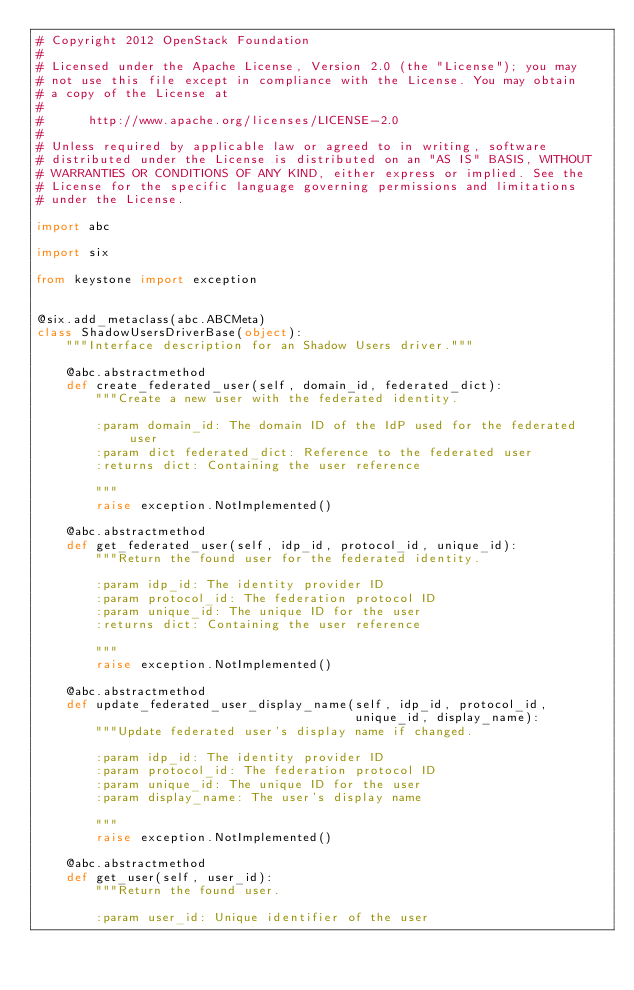Convert code to text. <code><loc_0><loc_0><loc_500><loc_500><_Python_># Copyright 2012 OpenStack Foundation
#
# Licensed under the Apache License, Version 2.0 (the "License"); you may
# not use this file except in compliance with the License. You may obtain
# a copy of the License at
#
#      http://www.apache.org/licenses/LICENSE-2.0
#
# Unless required by applicable law or agreed to in writing, software
# distributed under the License is distributed on an "AS IS" BASIS, WITHOUT
# WARRANTIES OR CONDITIONS OF ANY KIND, either express or implied. See the
# License for the specific language governing permissions and limitations
# under the License.

import abc

import six

from keystone import exception


@six.add_metaclass(abc.ABCMeta)
class ShadowUsersDriverBase(object):
    """Interface description for an Shadow Users driver."""

    @abc.abstractmethod
    def create_federated_user(self, domain_id, federated_dict):
        """Create a new user with the federated identity.

        :param domain_id: The domain ID of the IdP used for the federated user
        :param dict federated_dict: Reference to the federated user
        :returns dict: Containing the user reference

        """
        raise exception.NotImplemented()

    @abc.abstractmethod
    def get_federated_user(self, idp_id, protocol_id, unique_id):
        """Return the found user for the federated identity.

        :param idp_id: The identity provider ID
        :param protocol_id: The federation protocol ID
        :param unique_id: The unique ID for the user
        :returns dict: Containing the user reference

        """
        raise exception.NotImplemented()

    @abc.abstractmethod
    def update_federated_user_display_name(self, idp_id, protocol_id,
                                           unique_id, display_name):
        """Update federated user's display name if changed.

        :param idp_id: The identity provider ID
        :param protocol_id: The federation protocol ID
        :param unique_id: The unique ID for the user
        :param display_name: The user's display name

        """
        raise exception.NotImplemented()

    @abc.abstractmethod
    def get_user(self, user_id):
        """Return the found user.

        :param user_id: Unique identifier of the user</code> 